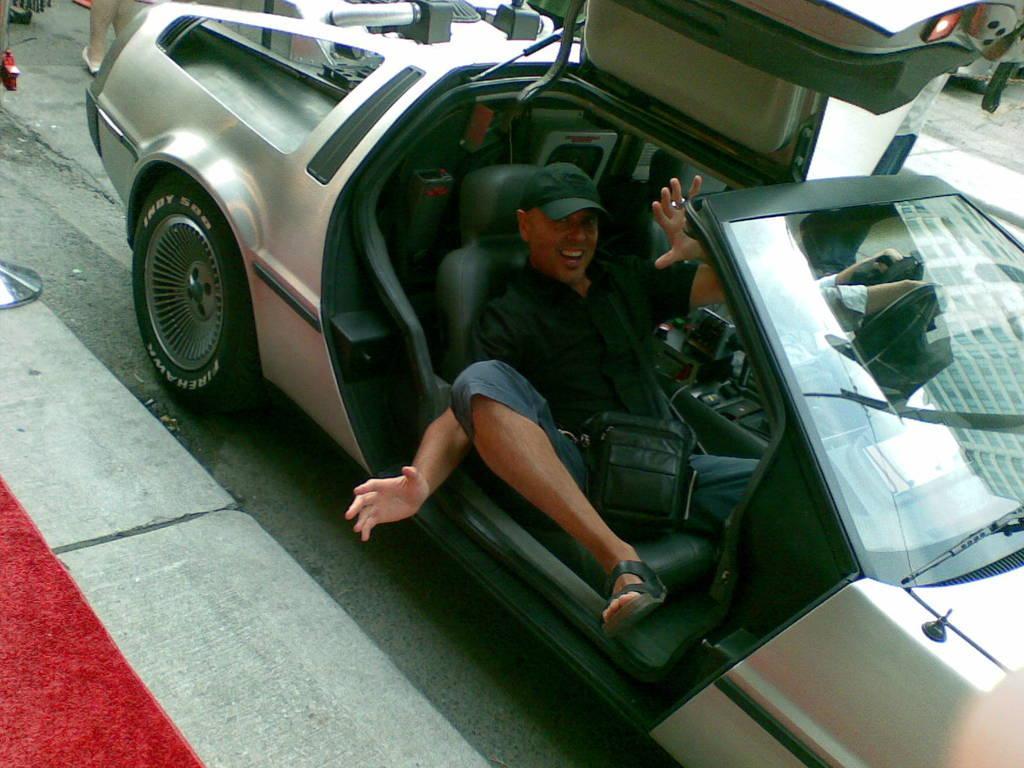Can you describe this image briefly? On the left we can see a carpet on a footpath and an object. There are two persons sitting in a car on the road. In the background we can see a person legs and some other objects on the road. 